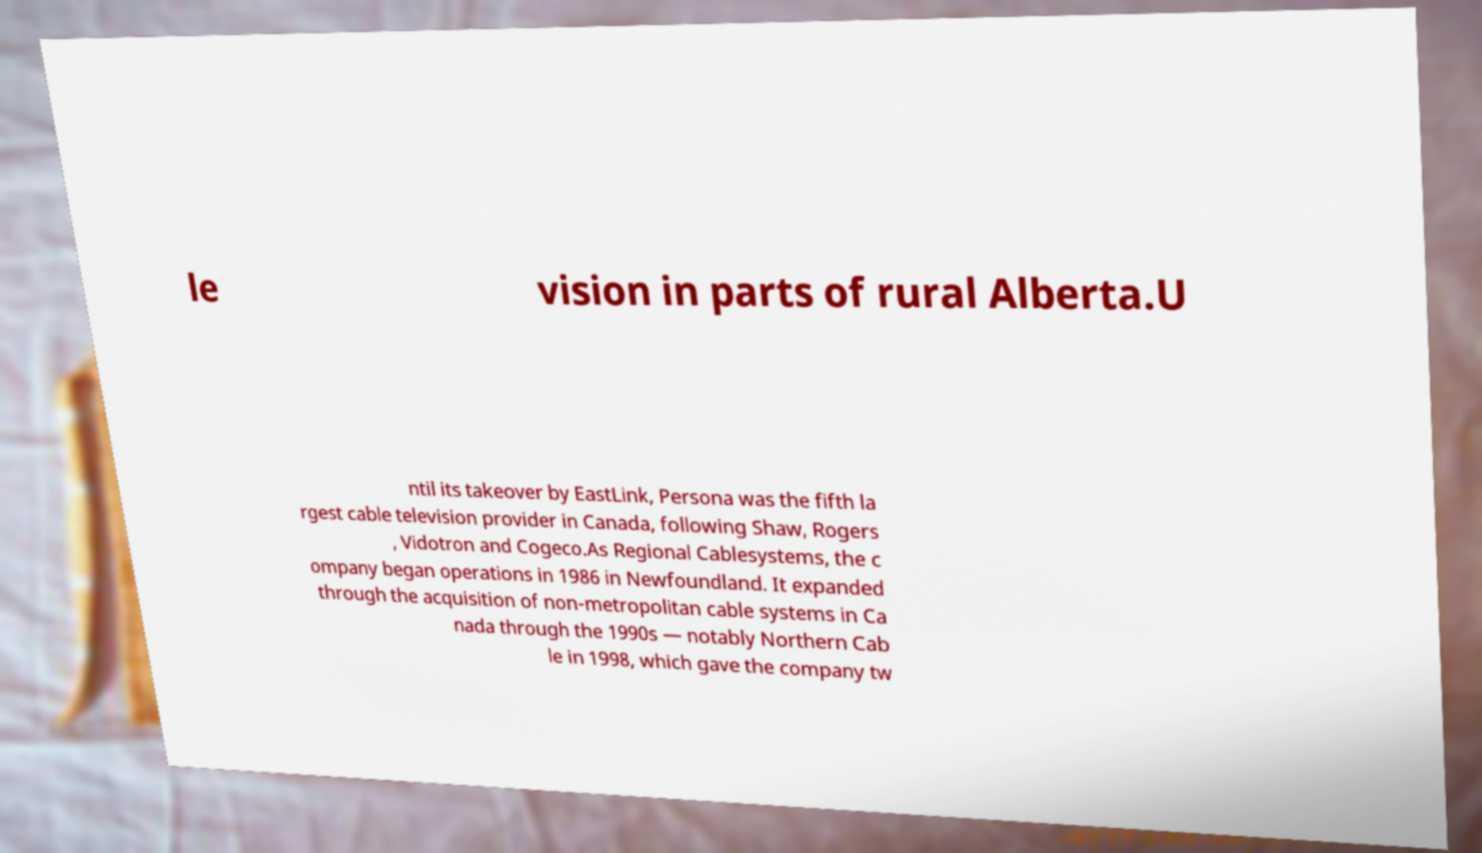I need the written content from this picture converted into text. Can you do that? le vision in parts of rural Alberta.U ntil its takeover by EastLink, Persona was the fifth la rgest cable television provider in Canada, following Shaw, Rogers , Vidotron and Cogeco.As Regional Cablesystems, the c ompany began operations in 1986 in Newfoundland. It expanded through the acquisition of non-metropolitan cable systems in Ca nada through the 1990s — notably Northern Cab le in 1998, which gave the company tw 